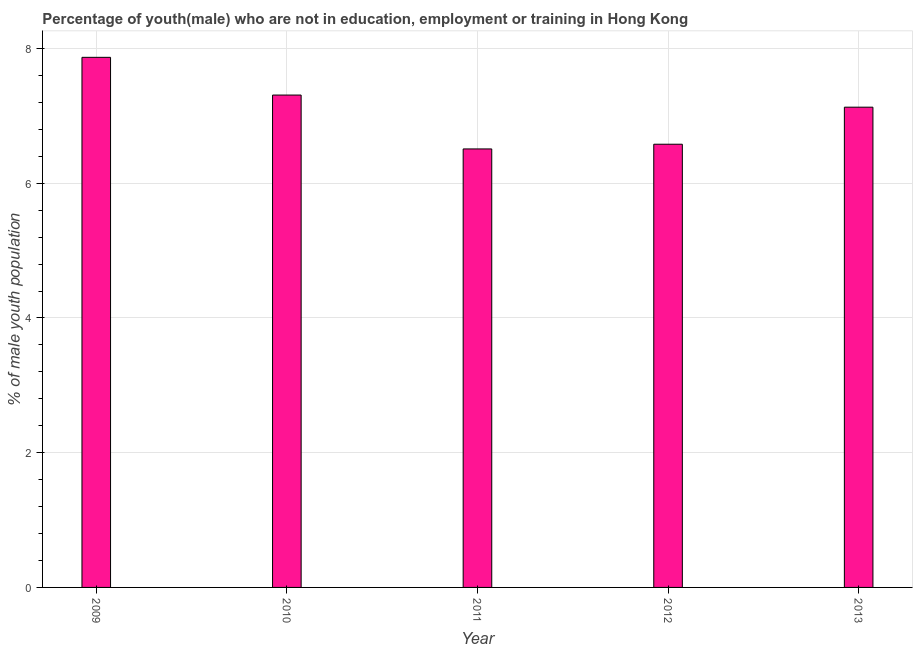What is the title of the graph?
Your answer should be compact. Percentage of youth(male) who are not in education, employment or training in Hong Kong. What is the label or title of the X-axis?
Offer a terse response. Year. What is the label or title of the Y-axis?
Ensure brevity in your answer.  % of male youth population. What is the unemployed male youth population in 2012?
Ensure brevity in your answer.  6.58. Across all years, what is the maximum unemployed male youth population?
Provide a short and direct response. 7.87. Across all years, what is the minimum unemployed male youth population?
Offer a very short reply. 6.51. What is the sum of the unemployed male youth population?
Your answer should be compact. 35.4. What is the average unemployed male youth population per year?
Offer a very short reply. 7.08. What is the median unemployed male youth population?
Ensure brevity in your answer.  7.13. Do a majority of the years between 2009 and 2010 (inclusive) have unemployed male youth population greater than 2.4 %?
Give a very brief answer. Yes. What is the ratio of the unemployed male youth population in 2009 to that in 2012?
Make the answer very short. 1.2. What is the difference between the highest and the second highest unemployed male youth population?
Ensure brevity in your answer.  0.56. Is the sum of the unemployed male youth population in 2010 and 2011 greater than the maximum unemployed male youth population across all years?
Your answer should be very brief. Yes. What is the difference between the highest and the lowest unemployed male youth population?
Your response must be concise. 1.36. How many years are there in the graph?
Provide a succinct answer. 5. What is the difference between two consecutive major ticks on the Y-axis?
Provide a succinct answer. 2. What is the % of male youth population in 2009?
Your answer should be very brief. 7.87. What is the % of male youth population in 2010?
Offer a very short reply. 7.31. What is the % of male youth population in 2011?
Keep it short and to the point. 6.51. What is the % of male youth population in 2012?
Keep it short and to the point. 6.58. What is the % of male youth population of 2013?
Make the answer very short. 7.13. What is the difference between the % of male youth population in 2009 and 2010?
Give a very brief answer. 0.56. What is the difference between the % of male youth population in 2009 and 2011?
Make the answer very short. 1.36. What is the difference between the % of male youth population in 2009 and 2012?
Keep it short and to the point. 1.29. What is the difference between the % of male youth population in 2009 and 2013?
Your answer should be compact. 0.74. What is the difference between the % of male youth population in 2010 and 2012?
Your response must be concise. 0.73. What is the difference between the % of male youth population in 2010 and 2013?
Offer a very short reply. 0.18. What is the difference between the % of male youth population in 2011 and 2012?
Your response must be concise. -0.07. What is the difference between the % of male youth population in 2011 and 2013?
Provide a succinct answer. -0.62. What is the difference between the % of male youth population in 2012 and 2013?
Your answer should be compact. -0.55. What is the ratio of the % of male youth population in 2009 to that in 2010?
Provide a short and direct response. 1.08. What is the ratio of the % of male youth population in 2009 to that in 2011?
Your response must be concise. 1.21. What is the ratio of the % of male youth population in 2009 to that in 2012?
Your response must be concise. 1.2. What is the ratio of the % of male youth population in 2009 to that in 2013?
Keep it short and to the point. 1.1. What is the ratio of the % of male youth population in 2010 to that in 2011?
Ensure brevity in your answer.  1.12. What is the ratio of the % of male youth population in 2010 to that in 2012?
Your answer should be very brief. 1.11. What is the ratio of the % of male youth population in 2010 to that in 2013?
Ensure brevity in your answer.  1.02. What is the ratio of the % of male youth population in 2011 to that in 2013?
Your response must be concise. 0.91. What is the ratio of the % of male youth population in 2012 to that in 2013?
Your answer should be very brief. 0.92. 